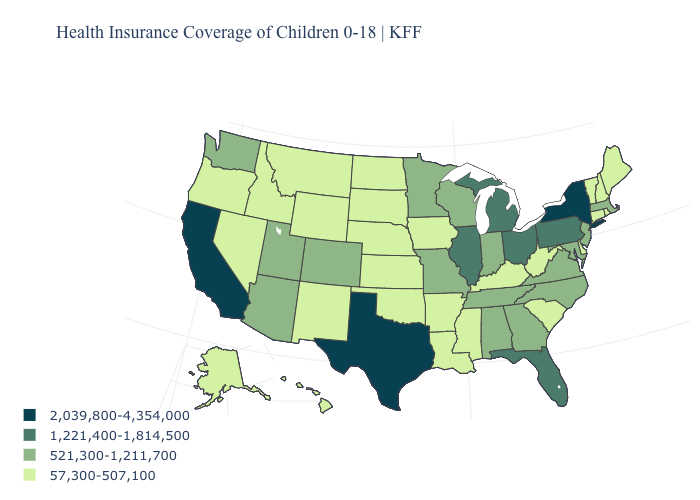Does California have the highest value in the USA?
Give a very brief answer. Yes. Which states have the lowest value in the USA?
Keep it brief. Alaska, Arkansas, Connecticut, Delaware, Hawaii, Idaho, Iowa, Kansas, Kentucky, Louisiana, Maine, Mississippi, Montana, Nebraska, Nevada, New Hampshire, New Mexico, North Dakota, Oklahoma, Oregon, Rhode Island, South Carolina, South Dakota, Vermont, West Virginia, Wyoming. Does Michigan have the highest value in the USA?
Short answer required. No. Which states have the highest value in the USA?
Answer briefly. California, New York, Texas. Name the states that have a value in the range 1,221,400-1,814,500?
Write a very short answer. Florida, Illinois, Michigan, Ohio, Pennsylvania. What is the lowest value in the USA?
Be succinct. 57,300-507,100. What is the highest value in states that border Florida?
Be succinct. 521,300-1,211,700. Does the first symbol in the legend represent the smallest category?
Give a very brief answer. No. What is the value of Illinois?
Give a very brief answer. 1,221,400-1,814,500. Among the states that border New Hampshire , which have the lowest value?
Quick response, please. Maine, Vermont. What is the value of Ohio?
Be succinct. 1,221,400-1,814,500. Which states have the lowest value in the USA?
Keep it brief. Alaska, Arkansas, Connecticut, Delaware, Hawaii, Idaho, Iowa, Kansas, Kentucky, Louisiana, Maine, Mississippi, Montana, Nebraska, Nevada, New Hampshire, New Mexico, North Dakota, Oklahoma, Oregon, Rhode Island, South Carolina, South Dakota, Vermont, West Virginia, Wyoming. Which states have the lowest value in the Northeast?
Concise answer only. Connecticut, Maine, New Hampshire, Rhode Island, Vermont. Name the states that have a value in the range 2,039,800-4,354,000?
Write a very short answer. California, New York, Texas. Does the map have missing data?
Answer briefly. No. 